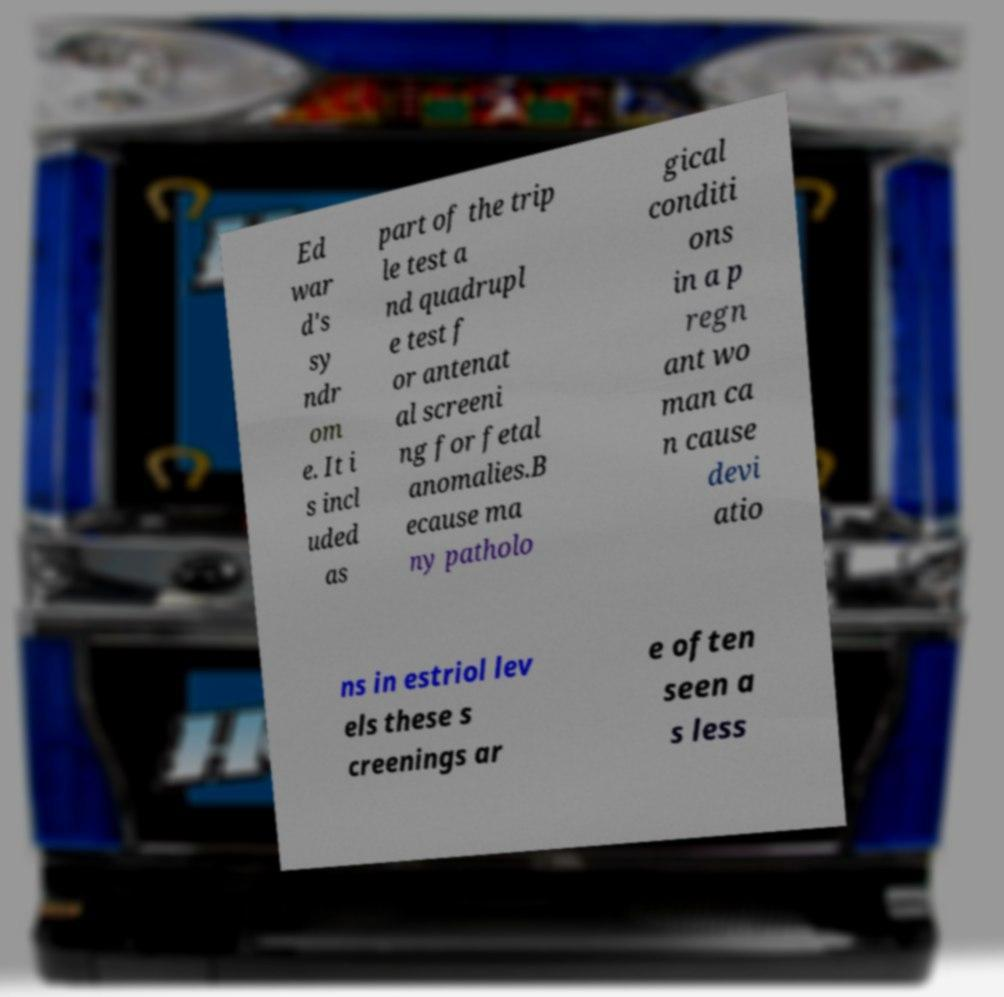Can you read and provide the text displayed in the image?This photo seems to have some interesting text. Can you extract and type it out for me? Ed war d's sy ndr om e. It i s incl uded as part of the trip le test a nd quadrupl e test f or antenat al screeni ng for fetal anomalies.B ecause ma ny patholo gical conditi ons in a p regn ant wo man ca n cause devi atio ns in estriol lev els these s creenings ar e often seen a s less 